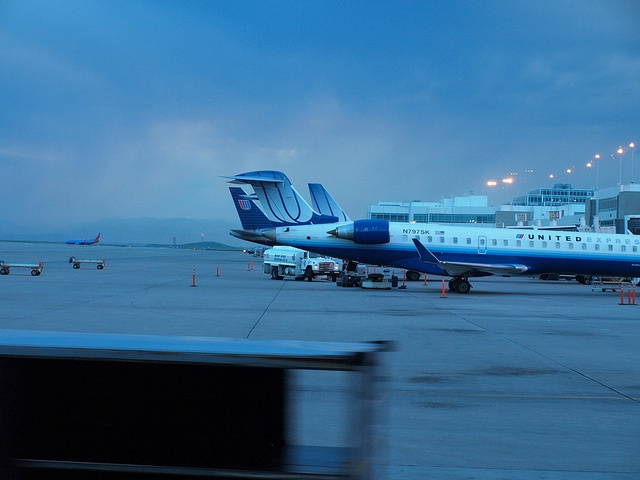Describe the objects in this image and their specific colors. I can see airplane in gray, navy, black, lightblue, and blue tones, truck in gray, black, lightblue, and blue tones, and airplane in gray, blue, and navy tones in this image. 